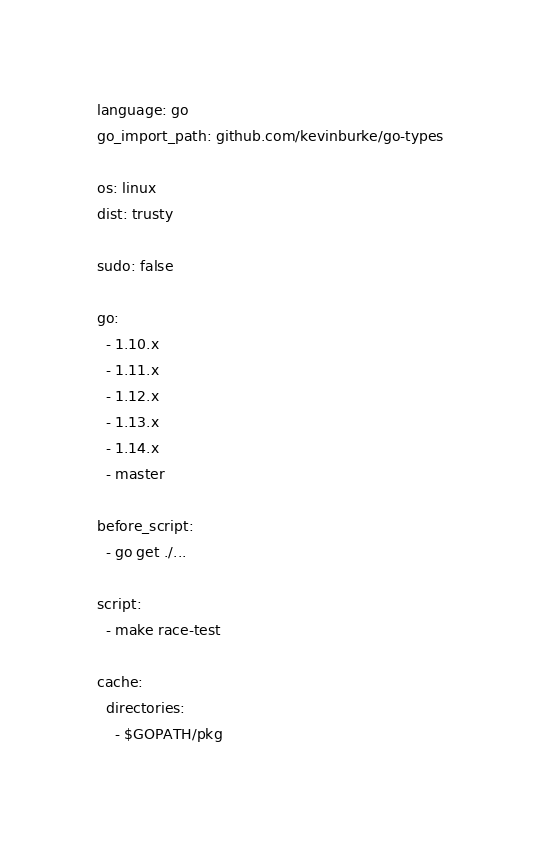Convert code to text. <code><loc_0><loc_0><loc_500><loc_500><_YAML_>language: go
go_import_path: github.com/kevinburke/go-types

os: linux
dist: trusty

sudo: false

go:
  - 1.10.x
  - 1.11.x
  - 1.12.x
  - 1.13.x
  - 1.14.x
  - master

before_script:
  - go get ./...

script:
  - make race-test

cache:
  directories:
    - $GOPATH/pkg
</code> 